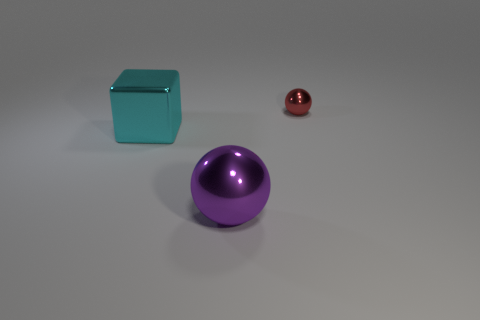Add 1 small rubber cubes. How many objects exist? 4 Subtract all blocks. How many objects are left? 2 Subtract 0 brown blocks. How many objects are left? 3 Subtract all small green rubber cubes. Subtract all cyan objects. How many objects are left? 2 Add 3 purple things. How many purple things are left? 4 Add 3 big red matte balls. How many big red matte balls exist? 3 